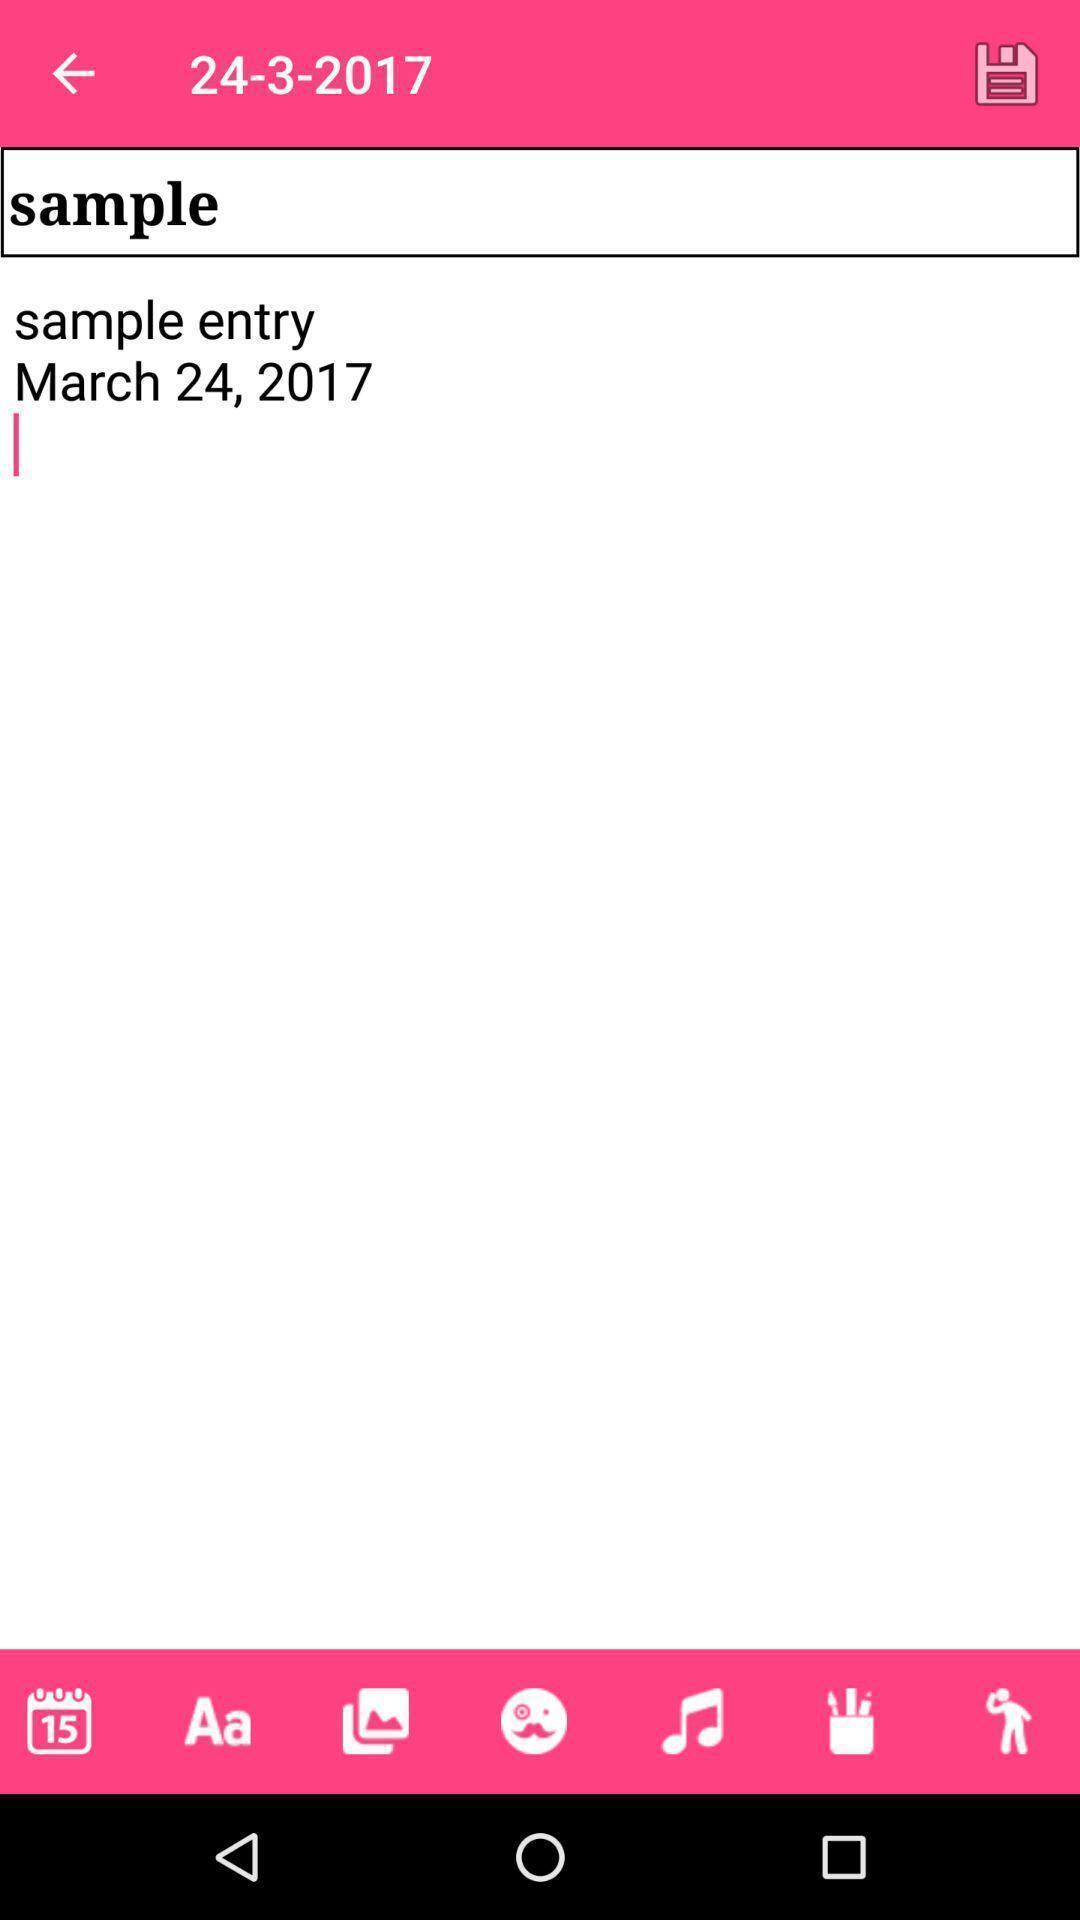Summarize the main components in this picture. Screen shows about a sample entry. 